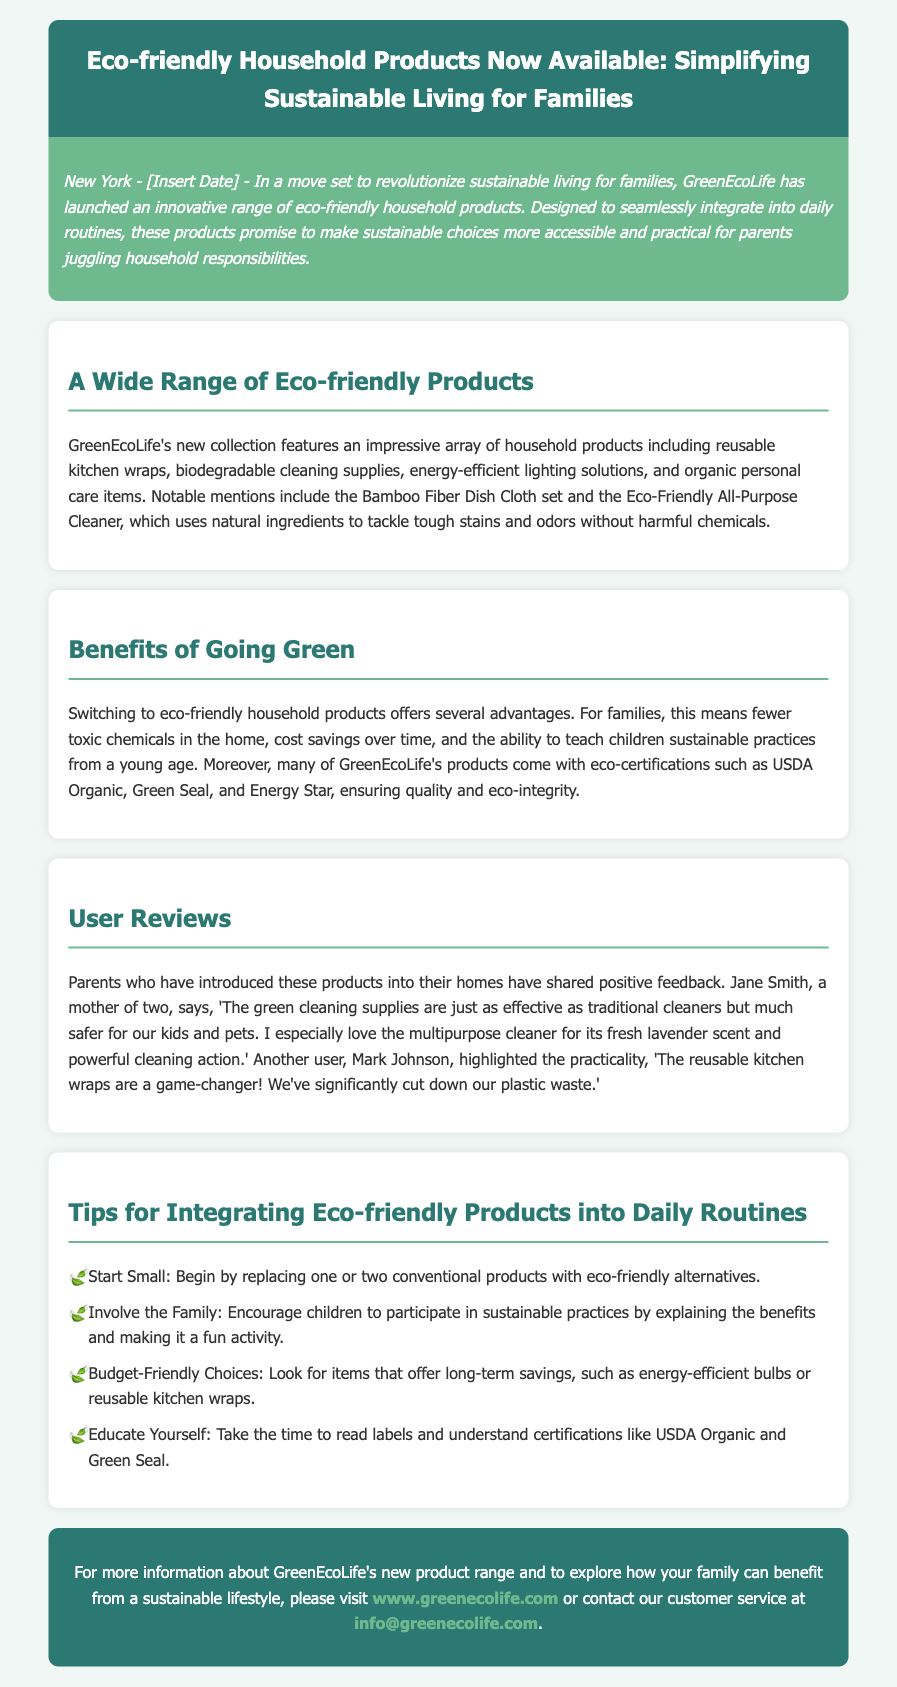What is the name of the company launching the new products? The company launching the products is mentioned in the introduction and is called GreenEcoLife.
Answer: GreenEcoLife What types of eco-friendly products are featured in the collection? The document lists a variety of products including reusable kitchen wraps, biodegradable cleaning supplies, energy-efficient lighting solutions, and organic personal care items.
Answer: Reusable kitchen wraps, biodegradable cleaning supplies, energy-efficient lighting solutions, and organic personal care items What eco-certifications do many of the products have? The document specifies eco-certifications such as USDA Organic, Green Seal, and Energy Star.
Answer: USDA Organic, Green Seal, and Energy Star What feedback did Jane Smith provide about the cleaning supplies? The review from Jane Smith highlights how the products are effective and safer for kids and pets, appreciating the multipurpose cleaner's fresh lavender scent and powerful cleaning action.
Answer: Just as effective as traditional cleaners, much safer for kids and pets, fresh lavender scent What is one of the tips for integrating eco-friendly products? The document lists several tips, and one of them is to start small by replacing one or two conventional products with eco-friendly alternatives.
Answer: Start Small What benefit of using eco-friendly products is mentioned for families? The document explains that families can experience fewer toxic chemicals in the home, which is a significant benefit.
Answer: Fewer toxic chemicals How does Mark Johnson describe the reusable kitchen wraps? Mark Johnson's review emphasizes that the reusable kitchen wraps are a game-changer and have significantly reduced their plastic waste.
Answer: A game-changer! Significant reduction in plastic waste What is the purpose of the press release? The purpose is to announce the launch of Eco-friendly household products and to simplify sustainable living for families.
Answer: Announce the launch of eco-friendly household products 